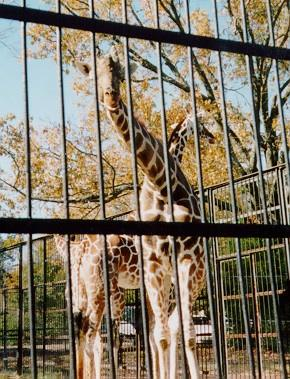What is between the is the fence made of? Please explain your reasoning. steel. The giraffe is behind a fence made of metal at a zoo. 